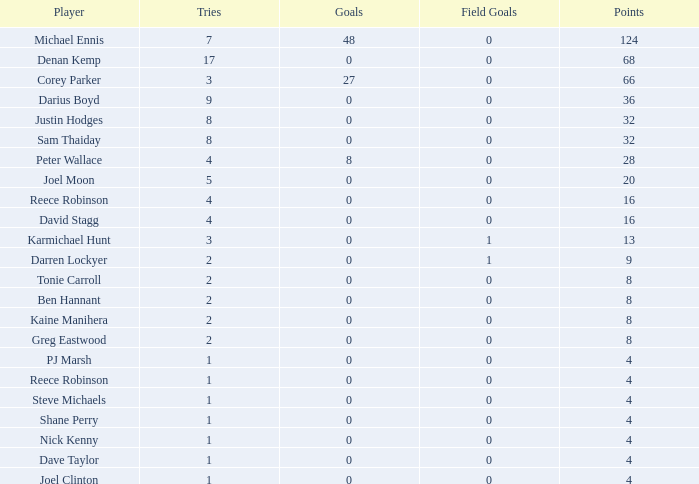How many points did the player with 2 tries and more than 0 field goals have? 9.0. 